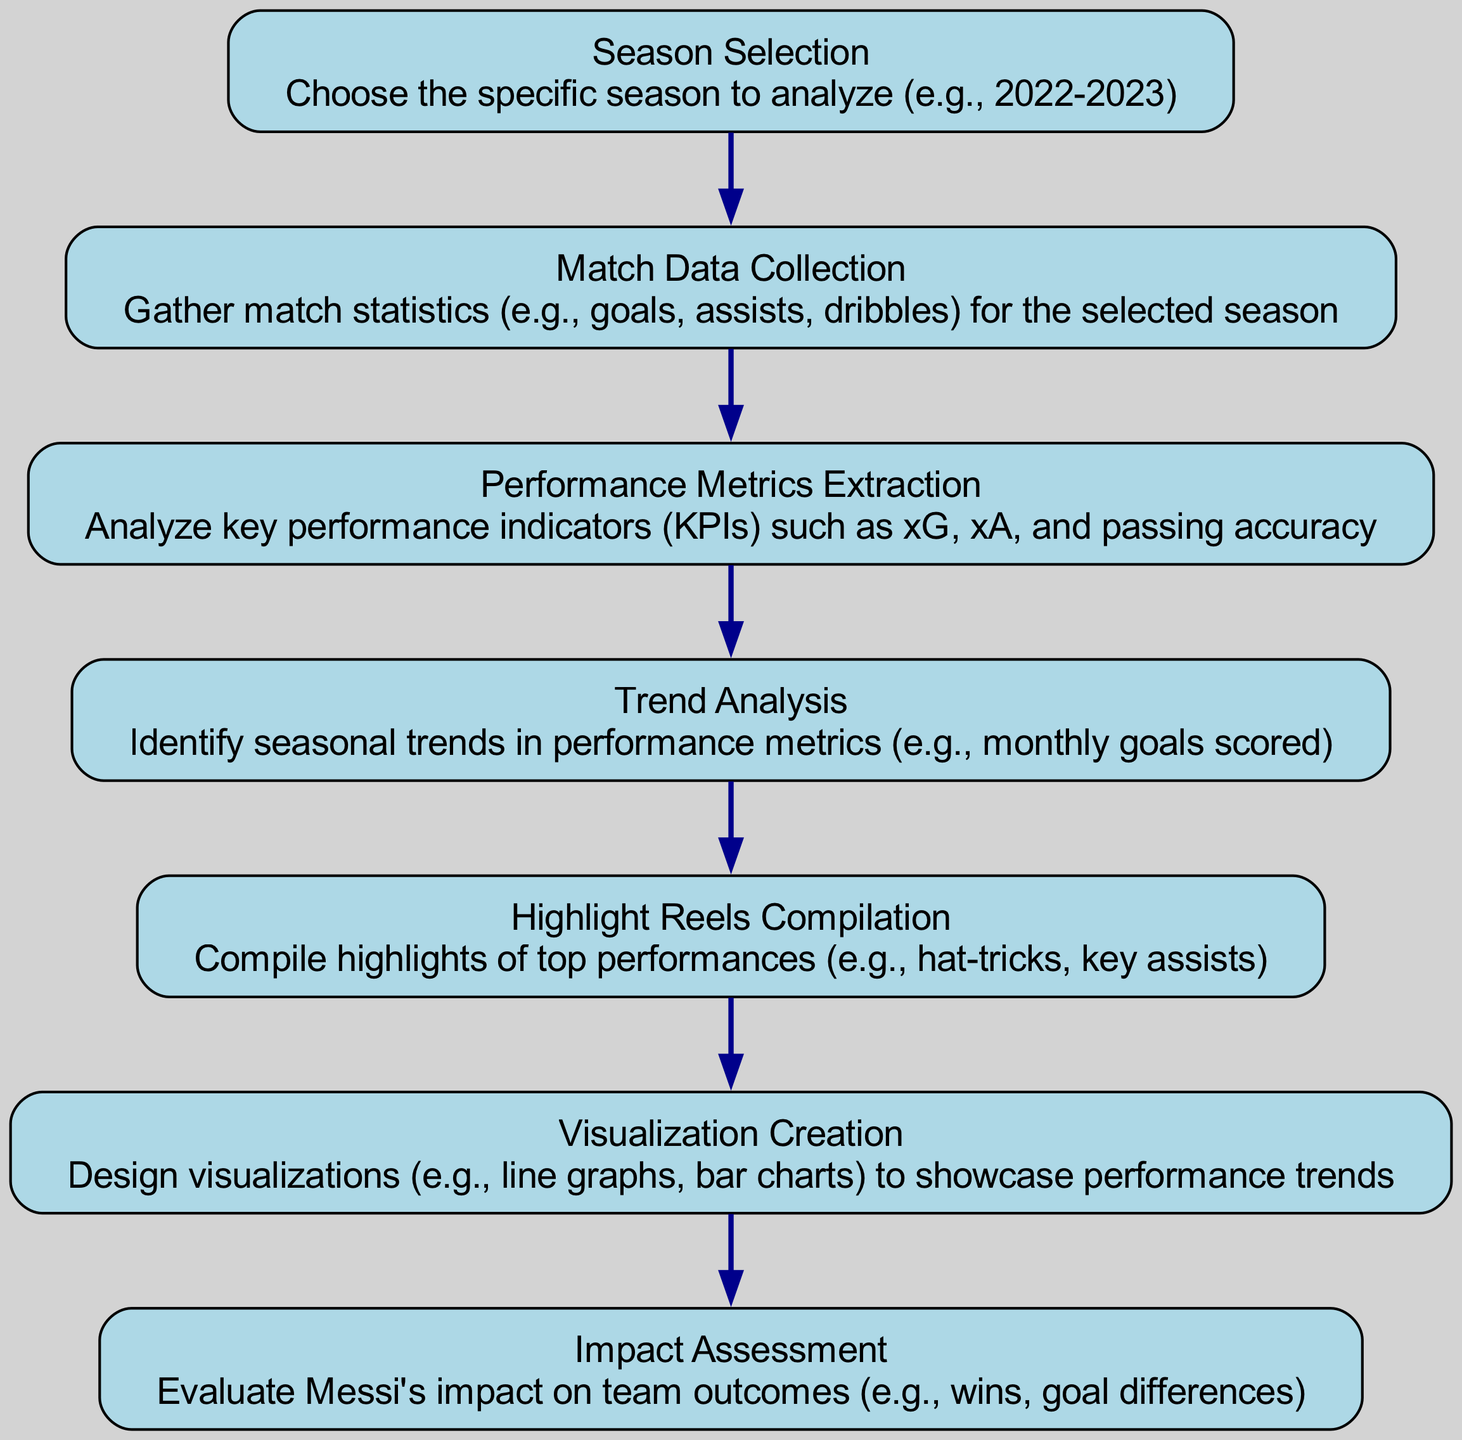What is the first step in the flow chart? The first step outlined in the flow chart is "Season Selection," which is where the specific season to analyze is chosen.
Answer: Season Selection How many nodes are present in the flow chart? There are a total of seven nodes present in the flow chart, corresponding to each step in the performance analysis process.
Answer: Seven What is the last step in the flow chart? The last step in the flow chart is "Impact Assessment," which involves evaluating Messi's impact on team outcomes.
Answer: Impact Assessment Which step follows "Trend Analysis"? The step that follows "Trend Analysis" is "Highlight Reels Compilation," indicating that after analyzing trends, highlights are compiled.
Answer: Highlight Reels Compilation What aspects are analyzed in the "Performance Metrics Extraction" step? In this step, key performance indicators such as expected goals (xG), expected assists (xA), and passing accuracy are analyzed.
Answer: xG, xA, passing accuracy What is the direct relationship between "Match Data Collection" and "Performance Metrics Extraction"? "Match Data Collection" directly feeds into "Performance Metrics Extraction," as match statistics gathered are essential for extracting performance metrics.
Answer: Data collection feeds metrics extraction Which two steps are linked directly by an edge besides the first one? "Trend Analysis" and "Highlight Reels Compilation" are linked directly by an edge, showing the order of process flow after performance metrics extraction.
Answer: Trend Analysis, Highlight Reels Compilation How does the flow chart represent the process of visualizations? The flow chart represents this process in the "Visualization Creation" step, which focuses on designing visualizations to showcase performance trends.
Answer: Visualization Creation What indicates the culmination of the analysis process in the flow chart? The culmination of the analysis process is indicated by reaching the "Impact Assessment" step, where the overall impact of Messi's performance is evaluated.
Answer: Impact Assessment 